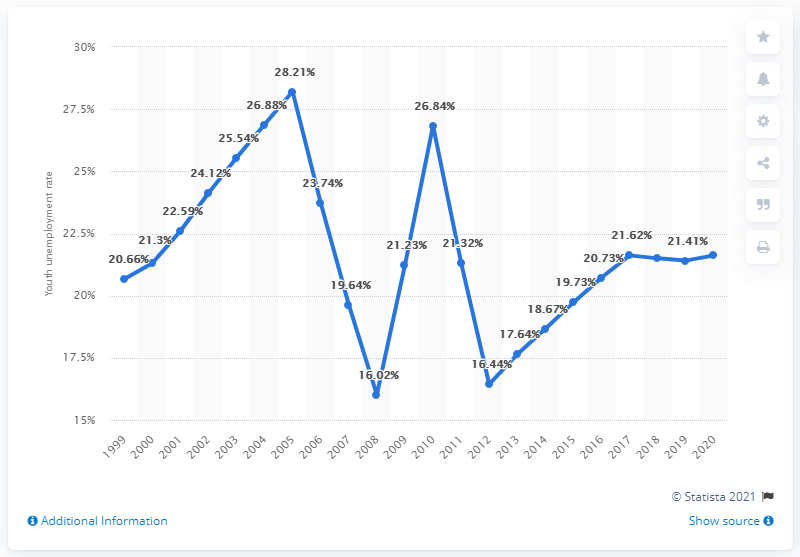Highlight a few significant elements in this photo. In 2020, the youth unemployment rate in Zambia was 21.62%. 